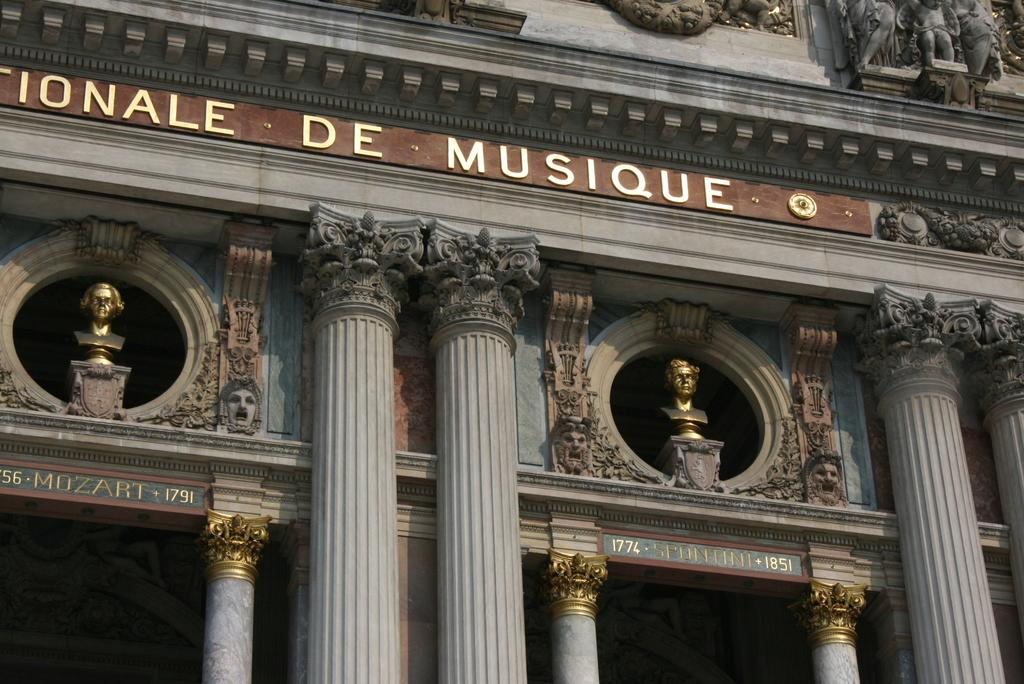What is depicted on the wall in the image? There are sculptures on the wall in the image. What else can be seen in the image besides the sculptures? There is text visible in the image. What architectural features are present in the image? There are pillars in the image. How many children are having lunch with their partner in the image? There are no children, lunch, or partners present in the image. The image features sculptures on the wall, text, and pillars. 